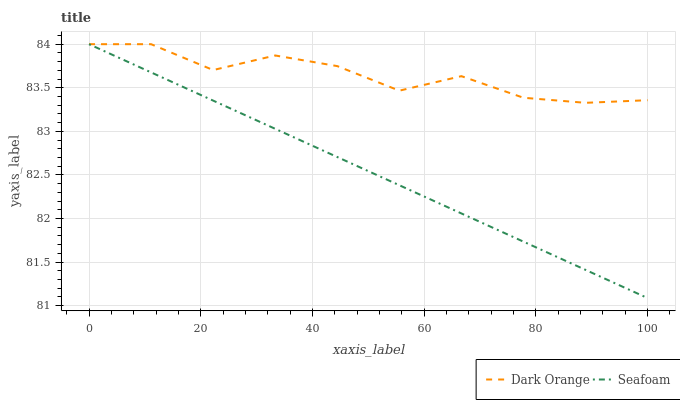Does Seafoam have the maximum area under the curve?
Answer yes or no. No. Is Seafoam the roughest?
Answer yes or no. No. 